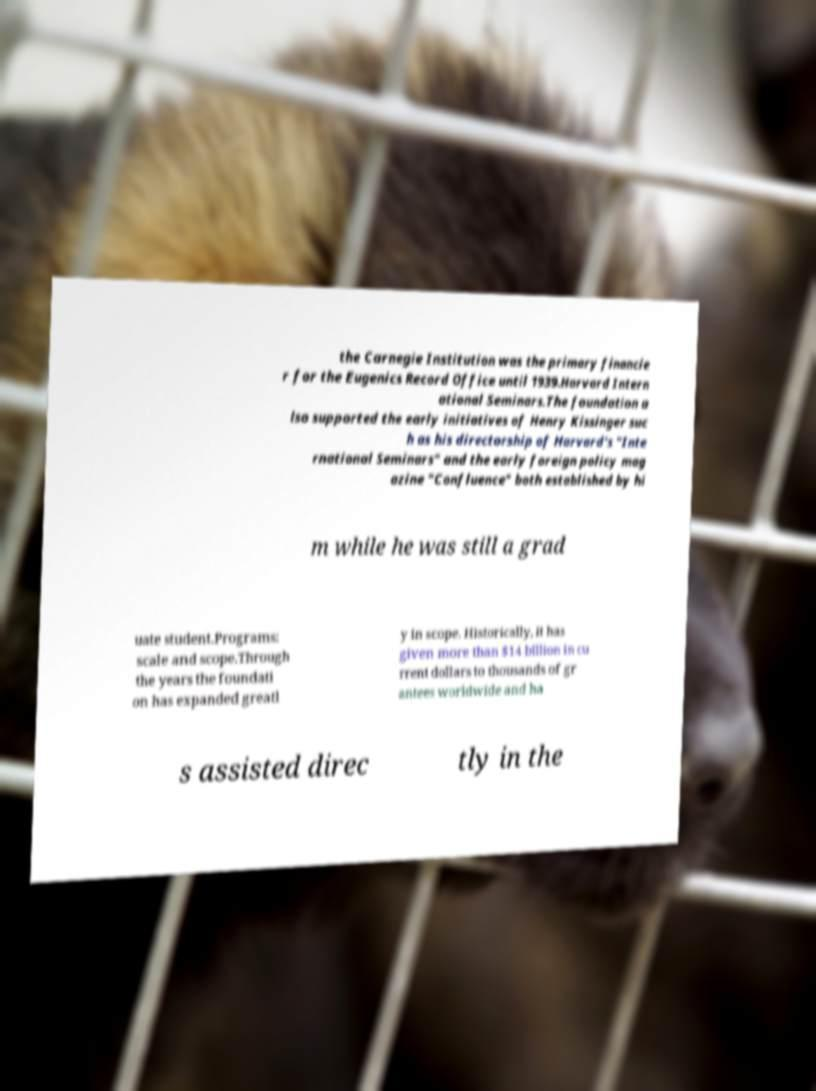Can you read and provide the text displayed in the image?This photo seems to have some interesting text. Can you extract and type it out for me? the Carnegie Institution was the primary financie r for the Eugenics Record Office until 1939.Harvard Intern ational Seminars.The foundation a lso supported the early initiatives of Henry Kissinger suc h as his directorship of Harvard's "Inte rnational Seminars" and the early foreign policy mag azine "Confluence" both established by hi m while he was still a grad uate student.Programs: scale and scope.Through the years the foundati on has expanded greatl y in scope. Historically, it has given more than $14 billion in cu rrent dollars to thousands of gr antees worldwide and ha s assisted direc tly in the 